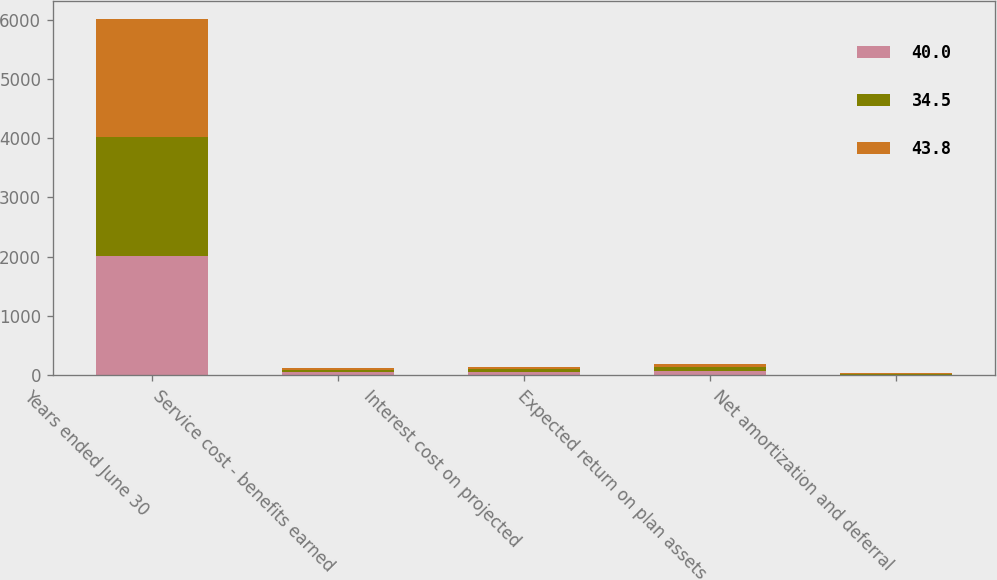<chart> <loc_0><loc_0><loc_500><loc_500><stacked_bar_chart><ecel><fcel>Years ended June 30<fcel>Service cost - benefits earned<fcel>Interest cost on projected<fcel>Expected return on plan assets<fcel>Net amortization and deferral<nl><fcel>40<fcel>2008<fcel>46.1<fcel>50.7<fcel>67.2<fcel>10.4<nl><fcel>34.5<fcel>2007<fcel>42.2<fcel>49<fcel>62<fcel>14.6<nl><fcel>43.8<fcel>2006<fcel>31.6<fcel>39.6<fcel>56<fcel>19.3<nl></chart> 